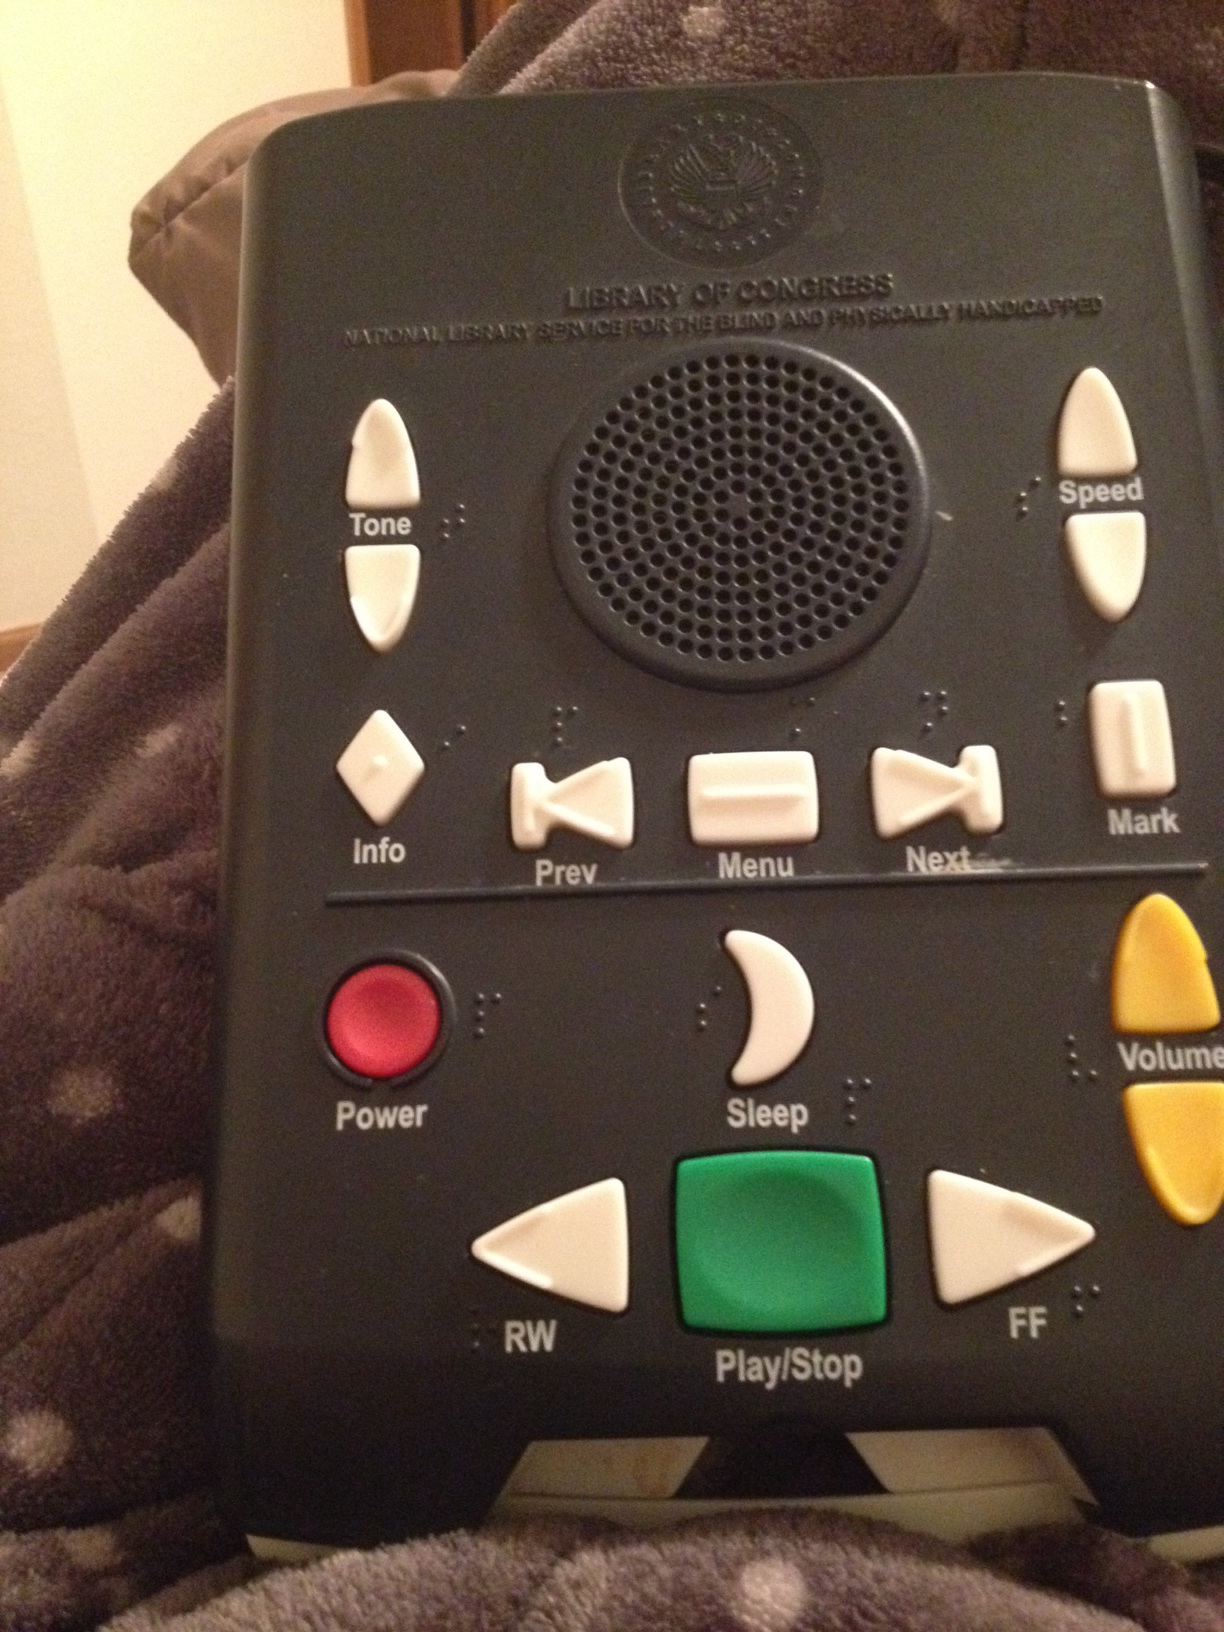What is the importance of such devices in the lives of people with visual impairments? Devices like these play a critical role in providing independence and enhancing the quality of life for individuals with visual impairments. They allow users to access a wide range of auditory content, such as books, magazines, and newspapers, which might otherwise be inaccessible. This helps in promoting education, entertainment, and information access, contributing significantly to personal development and inclusion in societal activities. 